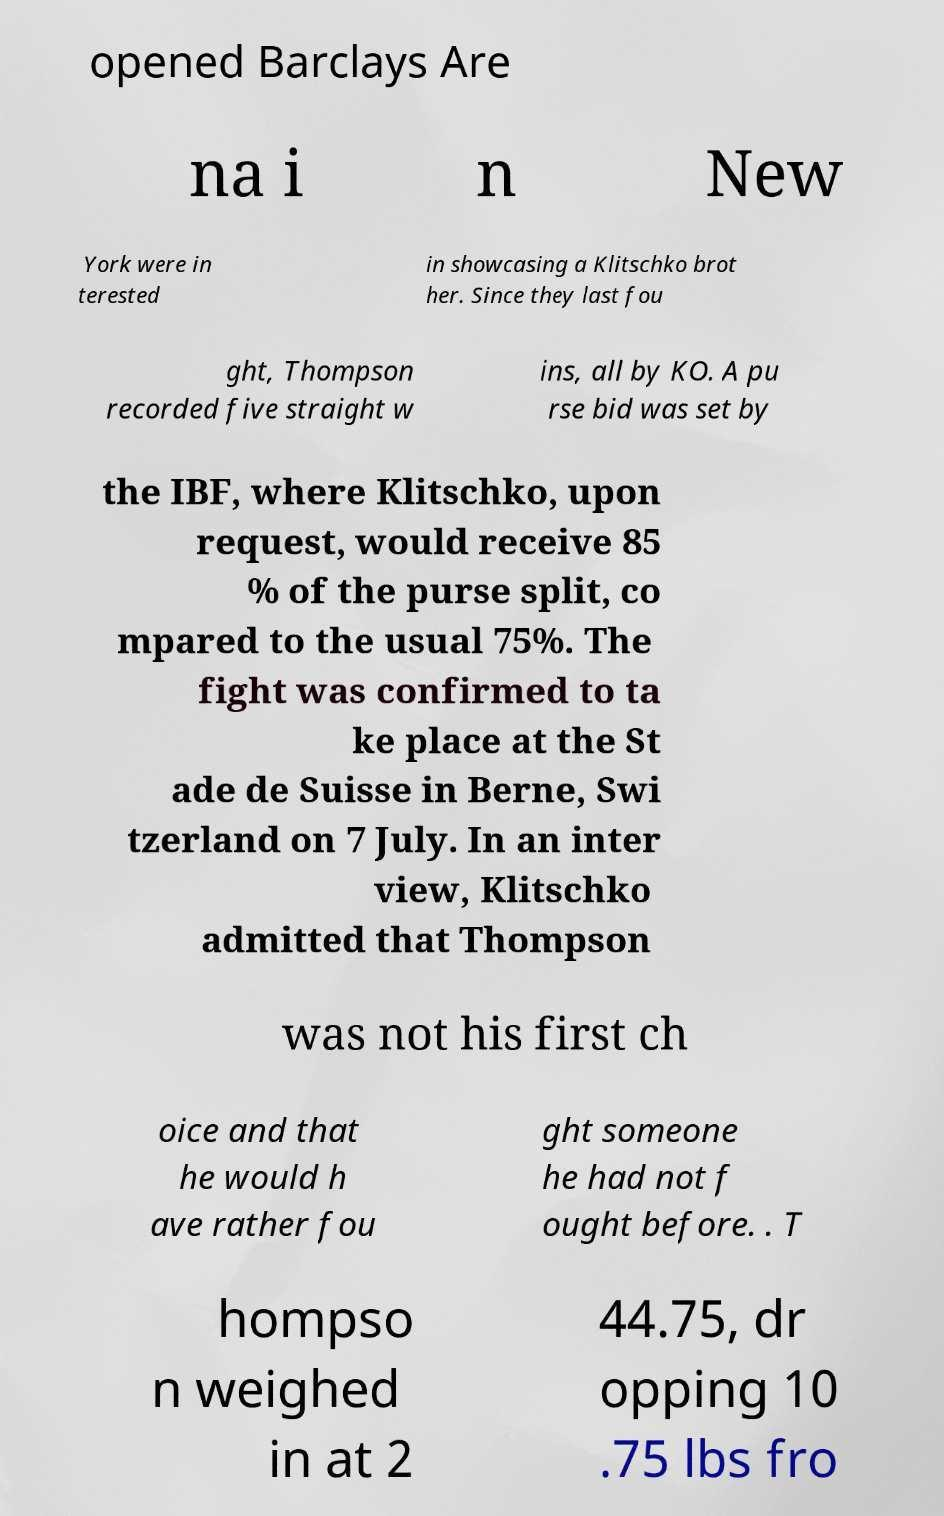For documentation purposes, I need the text within this image transcribed. Could you provide that? opened Barclays Are na i n New York were in terested in showcasing a Klitschko brot her. Since they last fou ght, Thompson recorded five straight w ins, all by KO. A pu rse bid was set by the IBF, where Klitschko, upon request, would receive 85 % of the purse split, co mpared to the usual 75%. The fight was confirmed to ta ke place at the St ade de Suisse in Berne, Swi tzerland on 7 July. In an inter view, Klitschko admitted that Thompson was not his first ch oice and that he would h ave rather fou ght someone he had not f ought before. . T hompso n weighed in at 2 44.75, dr opping 10 .75 lbs fro 